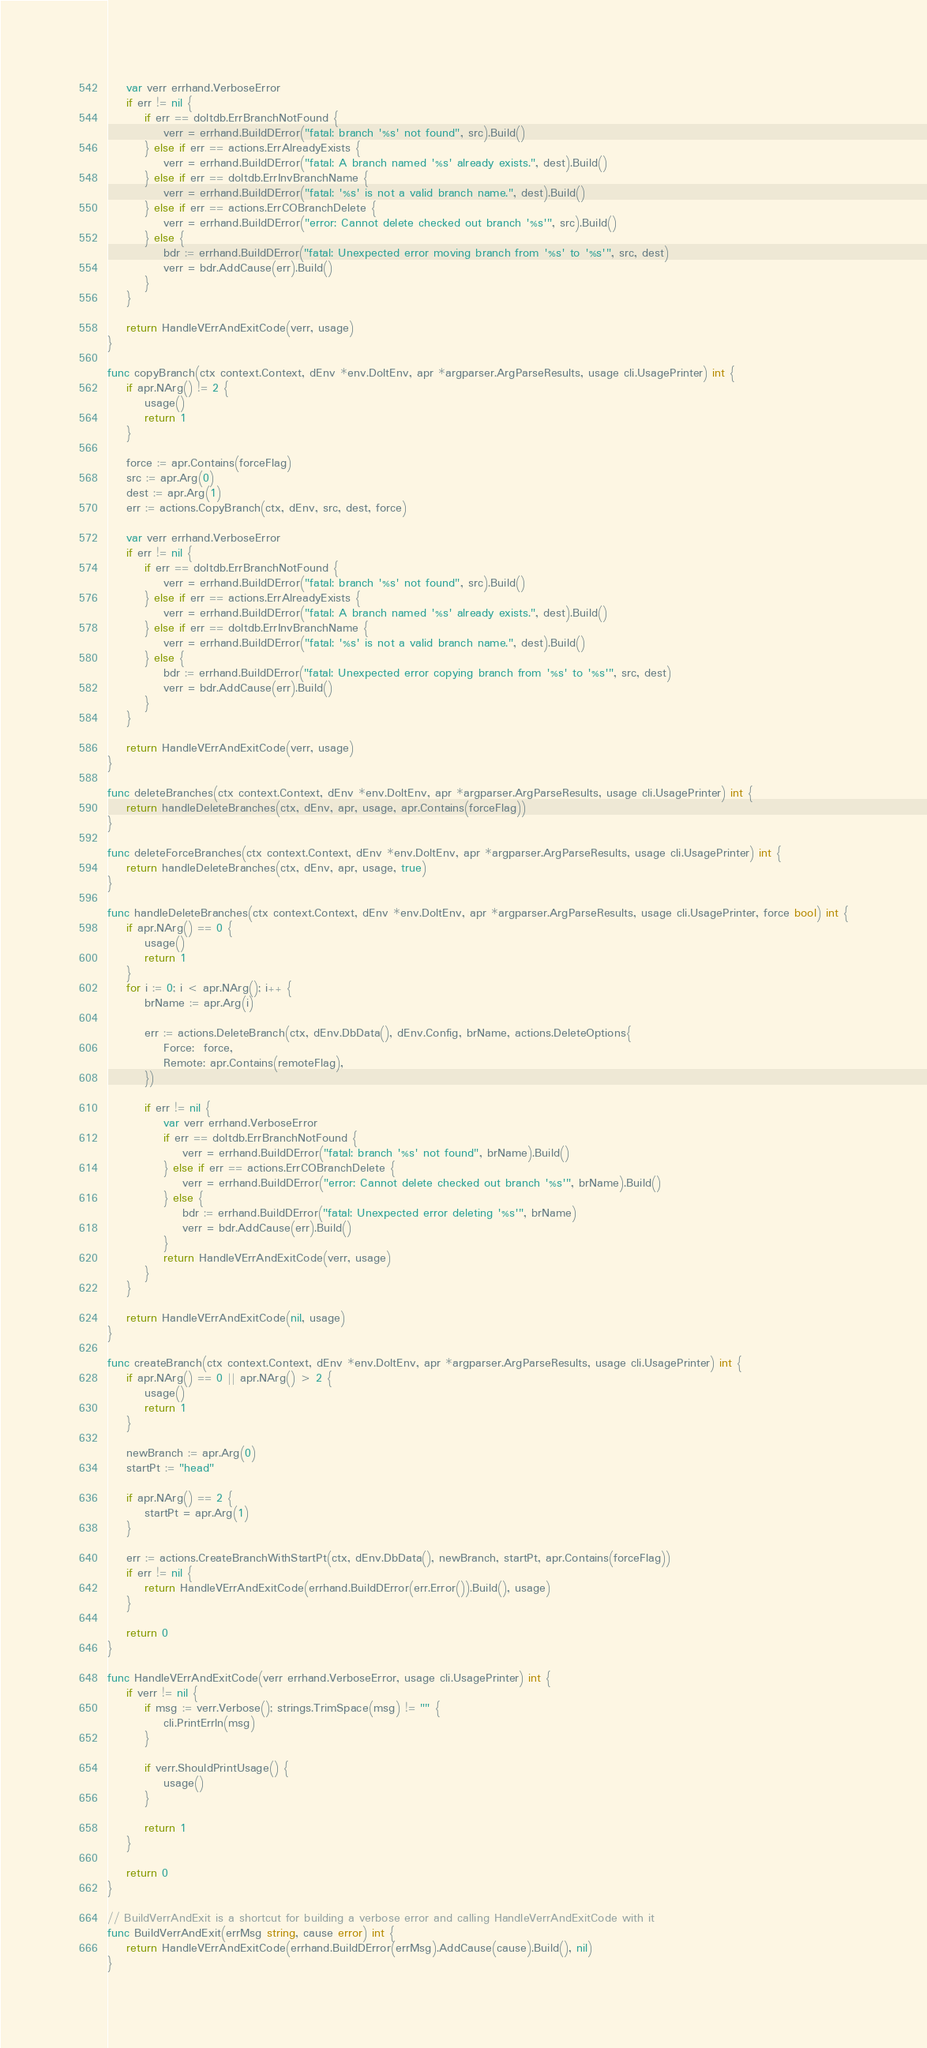Convert code to text. <code><loc_0><loc_0><loc_500><loc_500><_Go_>	var verr errhand.VerboseError
	if err != nil {
		if err == doltdb.ErrBranchNotFound {
			verr = errhand.BuildDError("fatal: branch '%s' not found", src).Build()
		} else if err == actions.ErrAlreadyExists {
			verr = errhand.BuildDError("fatal: A branch named '%s' already exists.", dest).Build()
		} else if err == doltdb.ErrInvBranchName {
			verr = errhand.BuildDError("fatal: '%s' is not a valid branch name.", dest).Build()
		} else if err == actions.ErrCOBranchDelete {
			verr = errhand.BuildDError("error: Cannot delete checked out branch '%s'", src).Build()
		} else {
			bdr := errhand.BuildDError("fatal: Unexpected error moving branch from '%s' to '%s'", src, dest)
			verr = bdr.AddCause(err).Build()
		}
	}

	return HandleVErrAndExitCode(verr, usage)
}

func copyBranch(ctx context.Context, dEnv *env.DoltEnv, apr *argparser.ArgParseResults, usage cli.UsagePrinter) int {
	if apr.NArg() != 2 {
		usage()
		return 1
	}

	force := apr.Contains(forceFlag)
	src := apr.Arg(0)
	dest := apr.Arg(1)
	err := actions.CopyBranch(ctx, dEnv, src, dest, force)

	var verr errhand.VerboseError
	if err != nil {
		if err == doltdb.ErrBranchNotFound {
			verr = errhand.BuildDError("fatal: branch '%s' not found", src).Build()
		} else if err == actions.ErrAlreadyExists {
			verr = errhand.BuildDError("fatal: A branch named '%s' already exists.", dest).Build()
		} else if err == doltdb.ErrInvBranchName {
			verr = errhand.BuildDError("fatal: '%s' is not a valid branch name.", dest).Build()
		} else {
			bdr := errhand.BuildDError("fatal: Unexpected error copying branch from '%s' to '%s'", src, dest)
			verr = bdr.AddCause(err).Build()
		}
	}

	return HandleVErrAndExitCode(verr, usage)
}

func deleteBranches(ctx context.Context, dEnv *env.DoltEnv, apr *argparser.ArgParseResults, usage cli.UsagePrinter) int {
	return handleDeleteBranches(ctx, dEnv, apr, usage, apr.Contains(forceFlag))
}

func deleteForceBranches(ctx context.Context, dEnv *env.DoltEnv, apr *argparser.ArgParseResults, usage cli.UsagePrinter) int {
	return handleDeleteBranches(ctx, dEnv, apr, usage, true)
}

func handleDeleteBranches(ctx context.Context, dEnv *env.DoltEnv, apr *argparser.ArgParseResults, usage cli.UsagePrinter, force bool) int {
	if apr.NArg() == 0 {
		usage()
		return 1
	}
	for i := 0; i < apr.NArg(); i++ {
		brName := apr.Arg(i)

		err := actions.DeleteBranch(ctx, dEnv.DbData(), dEnv.Config, brName, actions.DeleteOptions{
			Force:  force,
			Remote: apr.Contains(remoteFlag),
		})

		if err != nil {
			var verr errhand.VerboseError
			if err == doltdb.ErrBranchNotFound {
				verr = errhand.BuildDError("fatal: branch '%s' not found", brName).Build()
			} else if err == actions.ErrCOBranchDelete {
				verr = errhand.BuildDError("error: Cannot delete checked out branch '%s'", brName).Build()
			} else {
				bdr := errhand.BuildDError("fatal: Unexpected error deleting '%s'", brName)
				verr = bdr.AddCause(err).Build()
			}
			return HandleVErrAndExitCode(verr, usage)
		}
	}

	return HandleVErrAndExitCode(nil, usage)
}

func createBranch(ctx context.Context, dEnv *env.DoltEnv, apr *argparser.ArgParseResults, usage cli.UsagePrinter) int {
	if apr.NArg() == 0 || apr.NArg() > 2 {
		usage()
		return 1
	}

	newBranch := apr.Arg(0)
	startPt := "head"

	if apr.NArg() == 2 {
		startPt = apr.Arg(1)
	}

	err := actions.CreateBranchWithStartPt(ctx, dEnv.DbData(), newBranch, startPt, apr.Contains(forceFlag))
	if err != nil {
		return HandleVErrAndExitCode(errhand.BuildDError(err.Error()).Build(), usage)
	}

	return 0
}

func HandleVErrAndExitCode(verr errhand.VerboseError, usage cli.UsagePrinter) int {
	if verr != nil {
		if msg := verr.Verbose(); strings.TrimSpace(msg) != "" {
			cli.PrintErrln(msg)
		}

		if verr.ShouldPrintUsage() {
			usage()
		}

		return 1
	}

	return 0
}

// BuildVerrAndExit is a shortcut for building a verbose error and calling HandleVerrAndExitCode with it
func BuildVerrAndExit(errMsg string, cause error) int {
	return HandleVErrAndExitCode(errhand.BuildDError(errMsg).AddCause(cause).Build(), nil)
}
</code> 